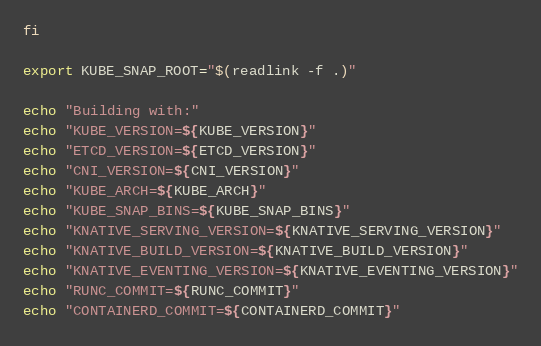Convert code to text. <code><loc_0><loc_0><loc_500><loc_500><_Bash_>fi

export KUBE_SNAP_ROOT="$(readlink -f .)"

echo "Building with:"
echo "KUBE_VERSION=${KUBE_VERSION}"
echo "ETCD_VERSION=${ETCD_VERSION}"
echo "CNI_VERSION=${CNI_VERSION}"
echo "KUBE_ARCH=${KUBE_ARCH}"
echo "KUBE_SNAP_BINS=${KUBE_SNAP_BINS}"
echo "KNATIVE_SERVING_VERSION=${KNATIVE_SERVING_VERSION}"
echo "KNATIVE_BUILD_VERSION=${KNATIVE_BUILD_VERSION}"
echo "KNATIVE_EVENTING_VERSION=${KNATIVE_EVENTING_VERSION}"
echo "RUNC_COMMIT=${RUNC_COMMIT}"
echo "CONTAINERD_COMMIT=${CONTAINERD_COMMIT}"
</code> 